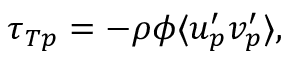<formula> <loc_0><loc_0><loc_500><loc_500>\tau _ { T p } = - \rho \phi \langle u _ { p } ^ { \prime } v _ { p } ^ { \prime } \rangle ,</formula> 